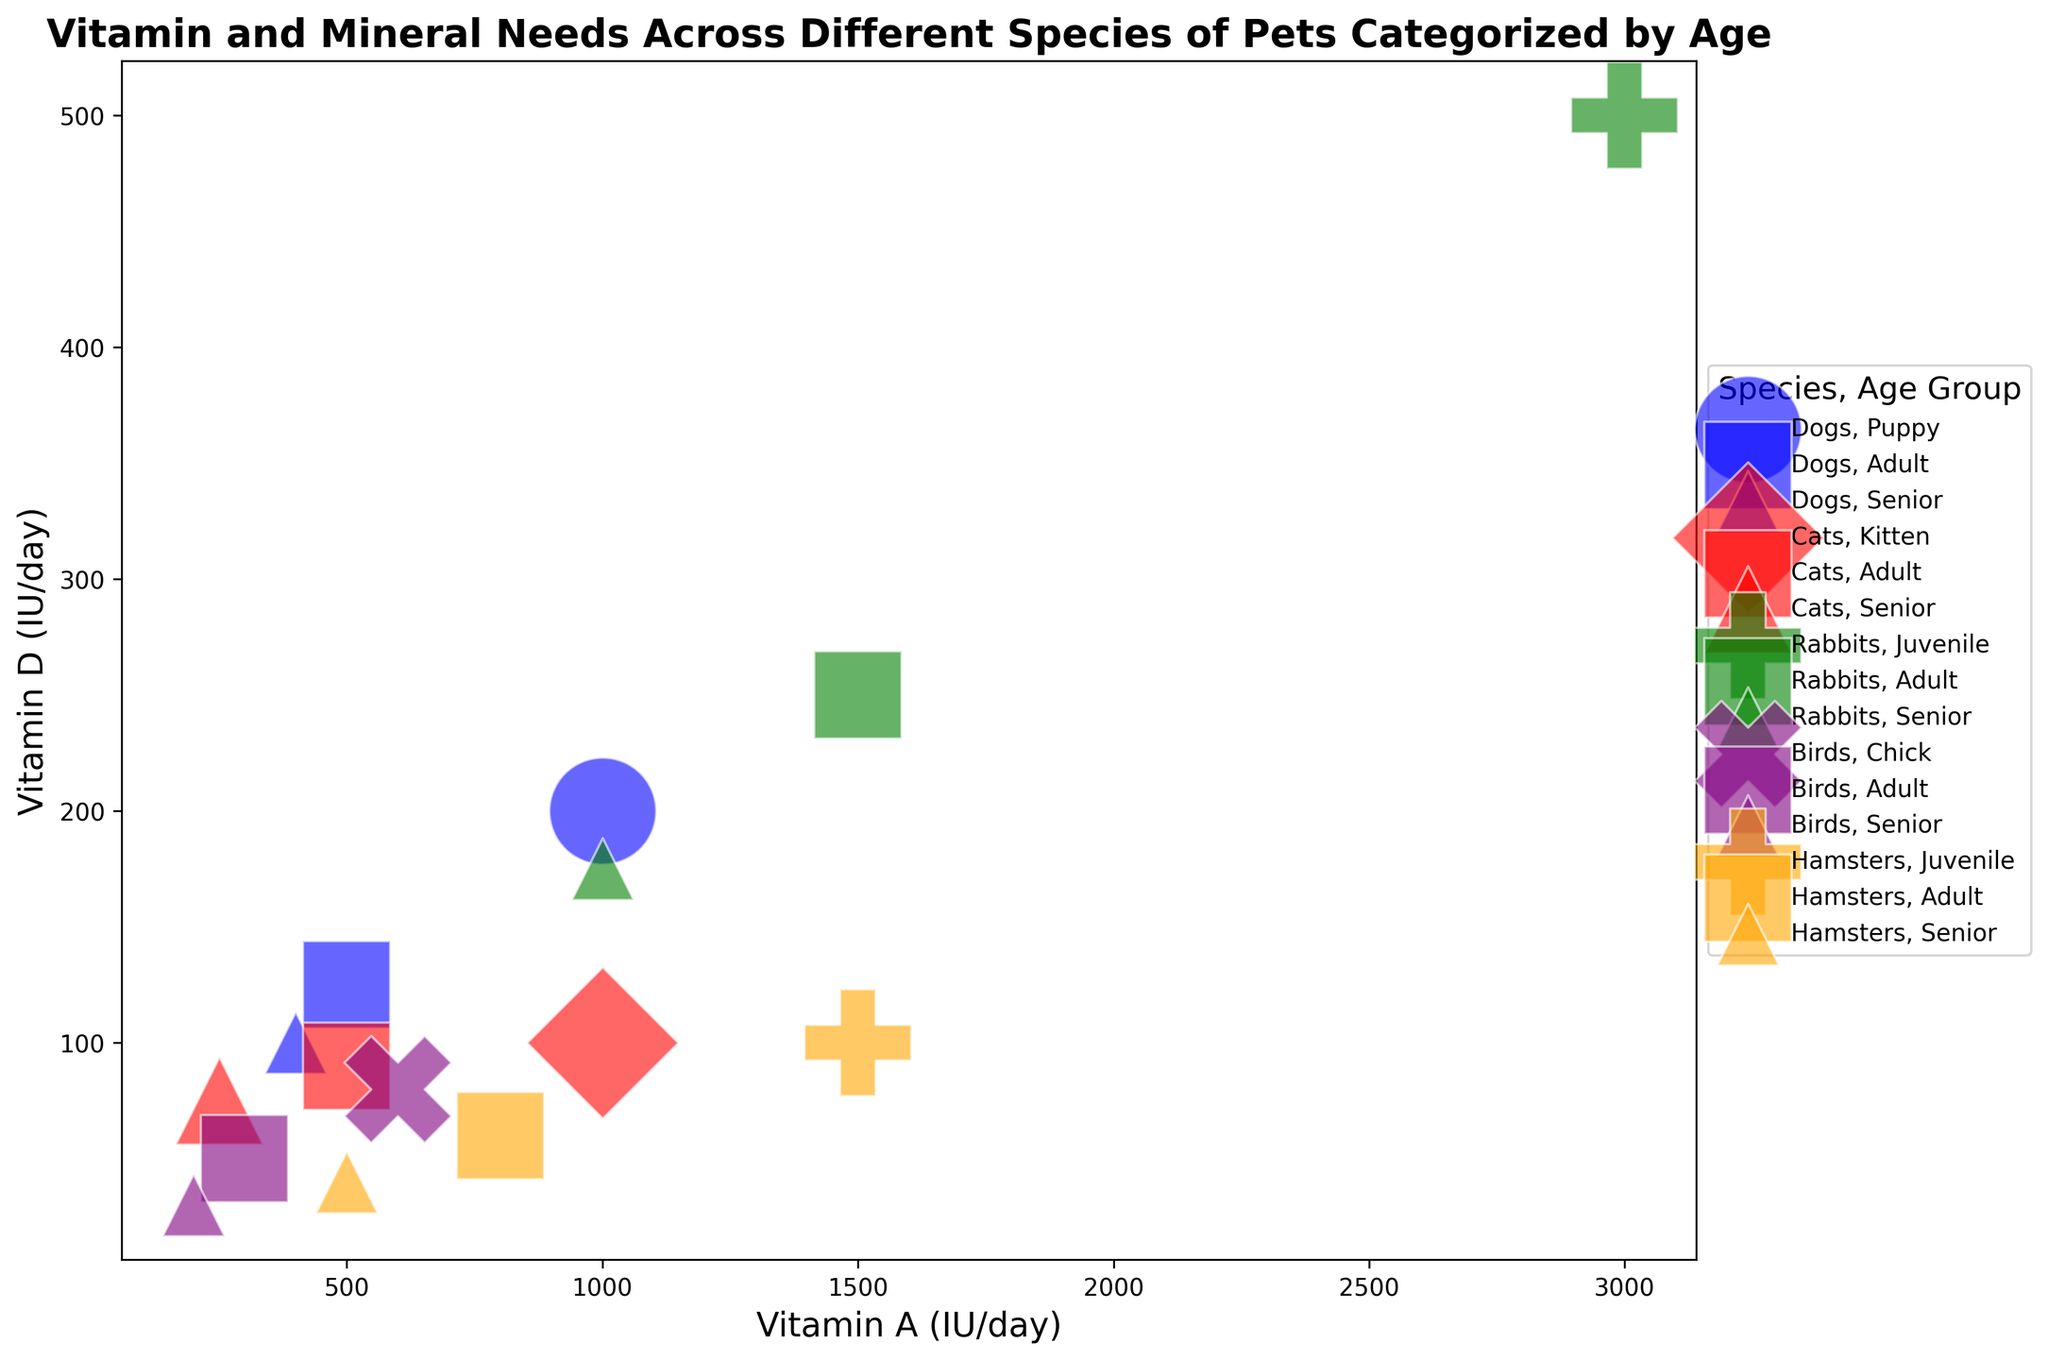Which species requires the highest intake of Vitamin D for juveniles? First, identify the juvenile groups in the legend, then compare the Vitamin D needs. Rabbits in the juvenile group have the highest Vitamin D requirement (500 IU/day).
Answer: Rabbits Which senior species needs the most Vitamin A daily? Look at the data points for the senior groups and compare their Vitamin A requirements. Rabbits require the most Vitamin A (1000 IU/day) among the senior species.
Answer: Rabbits Of the adult pets, which species have equal requirements for Vitamin A? Identify and compare the Vitamin A requirements of adult pets. Both Dogs and Cats adults require equal amounts of Vitamin A (500 IU/day).
Answer: Dogs and Cats Do juvenile rabbits require more Vitamin A than puppies? Compare the Vitamin A data points for juvenile rabbits and puppies. Juvenile rabbits need 3000 IU/day of Vitamin A, while puppies need 1000 IU/day.
Answer: Yes Which species has the lowest Vitamin D requirement for senior pets? Compare the Vitamin D needs for all senior pets shown in the legend. Birds have the lowest requirement (30 IU/day).
Answer: Birds Which group among all pets has the highest requirement for calcium? Find the data point where the calcium requirement is at its highest, which is among juvenile rabbits (1.5 g/day).
Answer: Juvenile Rabbits What is the difference in the Phosphorus needs between adult hamsters and senior hamsters? By examining the visual data, adult hamsters need 0.2 g/day of phosphorus and senior hamsters need 0.15 g/day. The difference is 0.2 - 0.15 = 0.05 g/day.
Answer: 0.05 g/day Which has greater importance, an adult bird or a senior cat, and how can you tell? Check the bubble size, which reflects the importance attribute. Adult birds with medium importance have larger bubbles compared to senior cats.
Answer: Adult birds Which species shows the greatest difference in vitamin A needs between the senior and juvenile age groups? Compare the senior and juvenile vitamin A requirements for each species and calculate the differences. The biggest gap is seen in rabbits, where juveniles need 3000 IU/day and seniors need 1000 IU/day, resulting in a difference of 2000 IU/day.
Answer: Rabbits Which age group of cats requires more daily Vitamin D: kittens or senior cats? Compare the data points of kittens and senior cats for their Vitamin D requirements. Kittens need 100 IU/day, while senior cats need 75 IU/day.
Answer: Kittens 